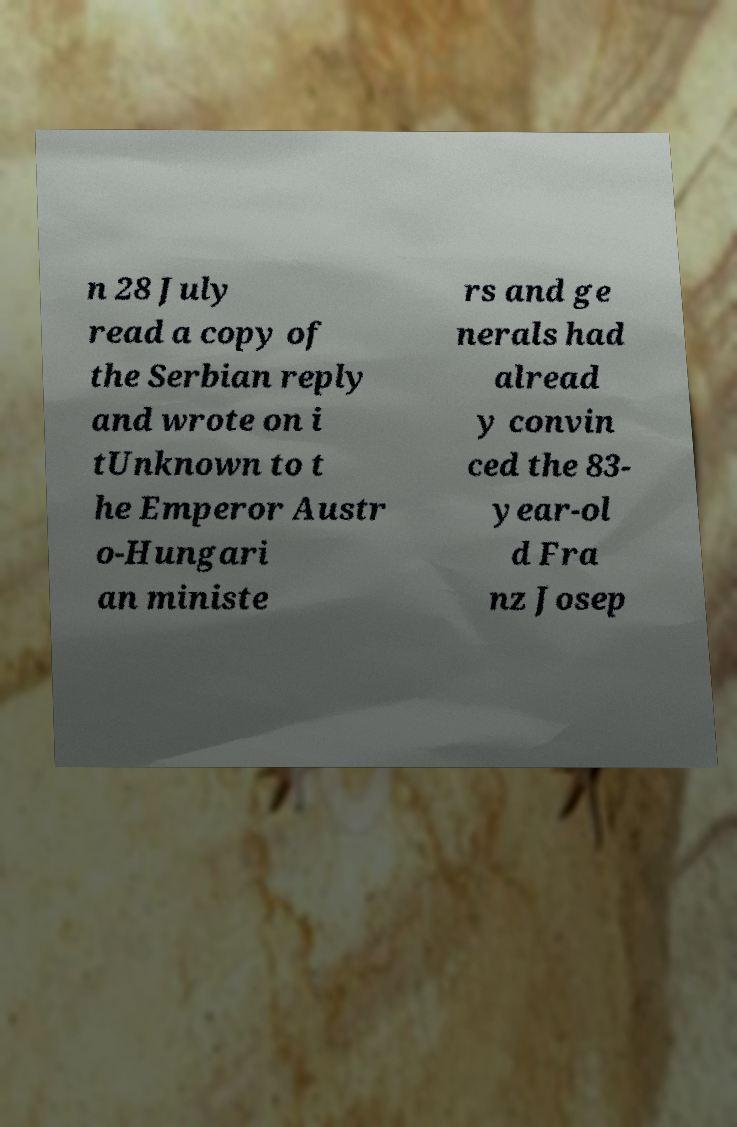Could you extract and type out the text from this image? n 28 July read a copy of the Serbian reply and wrote on i tUnknown to t he Emperor Austr o-Hungari an ministe rs and ge nerals had alread y convin ced the 83- year-ol d Fra nz Josep 